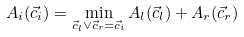<formula> <loc_0><loc_0><loc_500><loc_500>A _ { i } ( \vec { c } _ { i } ) = \min _ { \vec { c } _ { l } \vee \vec { c } _ { r } = \vec { c } _ { i } } A _ { l } ( \vec { c } _ { l } ) + A _ { r } ( \vec { c } _ { r } )</formula> 